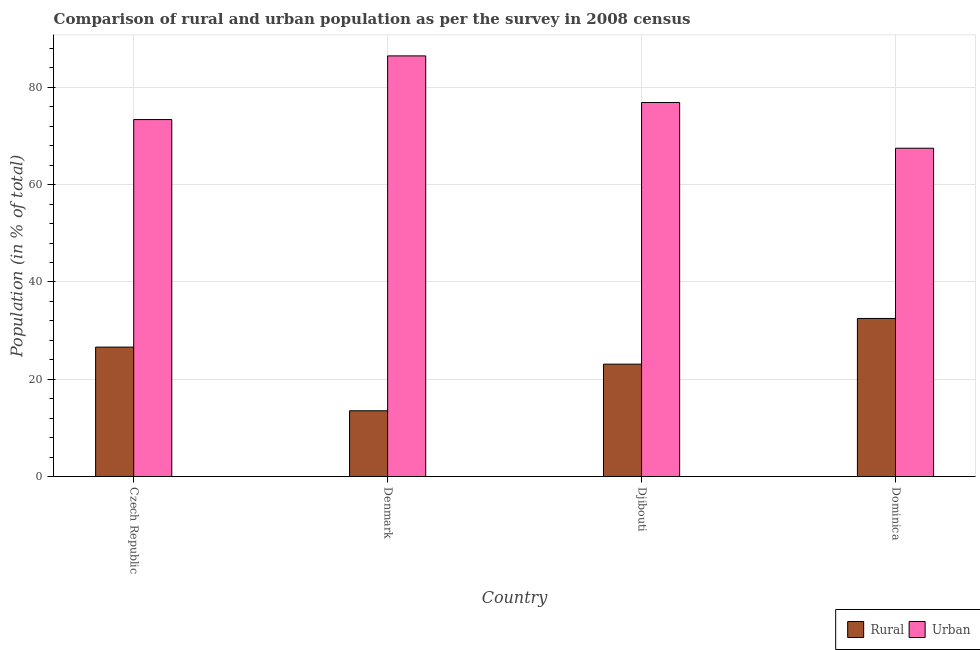How many bars are there on the 3rd tick from the right?
Keep it short and to the point. 2. What is the label of the 1st group of bars from the left?
Offer a terse response. Czech Republic. What is the urban population in Denmark?
Your response must be concise. 86.49. Across all countries, what is the maximum rural population?
Provide a succinct answer. 32.5. Across all countries, what is the minimum rural population?
Your answer should be compact. 13.51. In which country was the rural population maximum?
Give a very brief answer. Dominica. In which country was the urban population minimum?
Your response must be concise. Dominica. What is the total rural population in the graph?
Offer a very short reply. 95.72. What is the difference between the rural population in Denmark and that in Djibouti?
Keep it short and to the point. -9.59. What is the difference between the urban population in Djibouti and the rural population in Dominica?
Your answer should be very brief. 44.4. What is the average rural population per country?
Make the answer very short. 23.93. What is the difference between the rural population and urban population in Denmark?
Your response must be concise. -72.97. In how many countries, is the rural population greater than 12 %?
Make the answer very short. 4. What is the ratio of the urban population in Czech Republic to that in Djibouti?
Make the answer very short. 0.95. Is the difference between the rural population in Czech Republic and Dominica greater than the difference between the urban population in Czech Republic and Dominica?
Offer a very short reply. No. What is the difference between the highest and the second highest rural population?
Your answer should be compact. 5.89. What is the difference between the highest and the lowest urban population?
Your answer should be compact. 18.99. In how many countries, is the urban population greater than the average urban population taken over all countries?
Your response must be concise. 2. What does the 2nd bar from the left in Dominica represents?
Your answer should be very brief. Urban. What does the 2nd bar from the right in Denmark represents?
Give a very brief answer. Rural. How many bars are there?
Make the answer very short. 8. Are all the bars in the graph horizontal?
Your answer should be compact. No. What is the difference between two consecutive major ticks on the Y-axis?
Provide a short and direct response. 20. Are the values on the major ticks of Y-axis written in scientific E-notation?
Your answer should be compact. No. Does the graph contain grids?
Offer a terse response. Yes. How are the legend labels stacked?
Make the answer very short. Horizontal. What is the title of the graph?
Offer a very short reply. Comparison of rural and urban population as per the survey in 2008 census. What is the label or title of the Y-axis?
Make the answer very short. Population (in % of total). What is the Population (in % of total) of Rural in Czech Republic?
Ensure brevity in your answer.  26.61. What is the Population (in % of total) in Urban in Czech Republic?
Offer a terse response. 73.39. What is the Population (in % of total) in Rural in Denmark?
Your answer should be compact. 13.51. What is the Population (in % of total) of Urban in Denmark?
Your answer should be very brief. 86.49. What is the Population (in % of total) of Rural in Djibouti?
Your answer should be very brief. 23.1. What is the Population (in % of total) in Urban in Djibouti?
Provide a short and direct response. 76.9. What is the Population (in % of total) of Rural in Dominica?
Your answer should be compact. 32.5. What is the Population (in % of total) of Urban in Dominica?
Your answer should be compact. 67.5. Across all countries, what is the maximum Population (in % of total) in Rural?
Offer a very short reply. 32.5. Across all countries, what is the maximum Population (in % of total) in Urban?
Your answer should be compact. 86.49. Across all countries, what is the minimum Population (in % of total) in Rural?
Make the answer very short. 13.51. Across all countries, what is the minimum Population (in % of total) in Urban?
Ensure brevity in your answer.  67.5. What is the total Population (in % of total) in Rural in the graph?
Make the answer very short. 95.72. What is the total Population (in % of total) in Urban in the graph?
Provide a succinct answer. 304.28. What is the difference between the Population (in % of total) of Rural in Czech Republic and that in Denmark?
Offer a terse response. 13.09. What is the difference between the Population (in % of total) of Urban in Czech Republic and that in Denmark?
Make the answer very short. -13.09. What is the difference between the Population (in % of total) in Rural in Czech Republic and that in Djibouti?
Your response must be concise. 3.5. What is the difference between the Population (in % of total) of Urban in Czech Republic and that in Djibouti?
Ensure brevity in your answer.  -3.5. What is the difference between the Population (in % of total) of Rural in Czech Republic and that in Dominica?
Your response must be concise. -5.89. What is the difference between the Population (in % of total) of Urban in Czech Republic and that in Dominica?
Offer a terse response. 5.89. What is the difference between the Population (in % of total) of Rural in Denmark and that in Djibouti?
Ensure brevity in your answer.  -9.59. What is the difference between the Population (in % of total) in Urban in Denmark and that in Djibouti?
Make the answer very short. 9.59. What is the difference between the Population (in % of total) of Rural in Denmark and that in Dominica?
Your response must be concise. -18.98. What is the difference between the Population (in % of total) in Urban in Denmark and that in Dominica?
Offer a terse response. 18.98. What is the difference between the Population (in % of total) in Rural in Djibouti and that in Dominica?
Your response must be concise. -9.4. What is the difference between the Population (in % of total) of Urban in Djibouti and that in Dominica?
Offer a very short reply. 9.4. What is the difference between the Population (in % of total) of Rural in Czech Republic and the Population (in % of total) of Urban in Denmark?
Ensure brevity in your answer.  -59.88. What is the difference between the Population (in % of total) of Rural in Czech Republic and the Population (in % of total) of Urban in Djibouti?
Make the answer very short. -50.29. What is the difference between the Population (in % of total) of Rural in Czech Republic and the Population (in % of total) of Urban in Dominica?
Keep it short and to the point. -40.9. What is the difference between the Population (in % of total) in Rural in Denmark and the Population (in % of total) in Urban in Djibouti?
Ensure brevity in your answer.  -63.39. What is the difference between the Population (in % of total) in Rural in Denmark and the Population (in % of total) in Urban in Dominica?
Make the answer very short. -53.99. What is the difference between the Population (in % of total) of Rural in Djibouti and the Population (in % of total) of Urban in Dominica?
Your response must be concise. -44.4. What is the average Population (in % of total) in Rural per country?
Your answer should be compact. 23.93. What is the average Population (in % of total) in Urban per country?
Offer a very short reply. 76.07. What is the difference between the Population (in % of total) in Rural and Population (in % of total) in Urban in Czech Republic?
Ensure brevity in your answer.  -46.79. What is the difference between the Population (in % of total) in Rural and Population (in % of total) in Urban in Denmark?
Your answer should be compact. -72.97. What is the difference between the Population (in % of total) of Rural and Population (in % of total) of Urban in Djibouti?
Keep it short and to the point. -53.8. What is the difference between the Population (in % of total) in Rural and Population (in % of total) in Urban in Dominica?
Your answer should be compact. -35. What is the ratio of the Population (in % of total) of Rural in Czech Republic to that in Denmark?
Your answer should be very brief. 1.97. What is the ratio of the Population (in % of total) in Urban in Czech Republic to that in Denmark?
Provide a succinct answer. 0.85. What is the ratio of the Population (in % of total) in Rural in Czech Republic to that in Djibouti?
Your response must be concise. 1.15. What is the ratio of the Population (in % of total) of Urban in Czech Republic to that in Djibouti?
Your response must be concise. 0.95. What is the ratio of the Population (in % of total) of Rural in Czech Republic to that in Dominica?
Keep it short and to the point. 0.82. What is the ratio of the Population (in % of total) of Urban in Czech Republic to that in Dominica?
Keep it short and to the point. 1.09. What is the ratio of the Population (in % of total) of Rural in Denmark to that in Djibouti?
Make the answer very short. 0.58. What is the ratio of the Population (in % of total) in Urban in Denmark to that in Djibouti?
Offer a terse response. 1.12. What is the ratio of the Population (in % of total) of Rural in Denmark to that in Dominica?
Keep it short and to the point. 0.42. What is the ratio of the Population (in % of total) of Urban in Denmark to that in Dominica?
Make the answer very short. 1.28. What is the ratio of the Population (in % of total) of Rural in Djibouti to that in Dominica?
Provide a succinct answer. 0.71. What is the ratio of the Population (in % of total) of Urban in Djibouti to that in Dominica?
Offer a very short reply. 1.14. What is the difference between the highest and the second highest Population (in % of total) of Rural?
Make the answer very short. 5.89. What is the difference between the highest and the second highest Population (in % of total) of Urban?
Your answer should be compact. 9.59. What is the difference between the highest and the lowest Population (in % of total) in Rural?
Provide a short and direct response. 18.98. What is the difference between the highest and the lowest Population (in % of total) in Urban?
Offer a terse response. 18.98. 